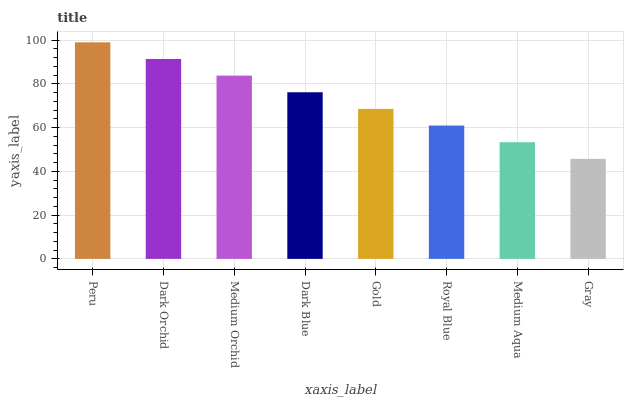Is Gray the minimum?
Answer yes or no. Yes. Is Peru the maximum?
Answer yes or no. Yes. Is Dark Orchid the minimum?
Answer yes or no. No. Is Dark Orchid the maximum?
Answer yes or no. No. Is Peru greater than Dark Orchid?
Answer yes or no. Yes. Is Dark Orchid less than Peru?
Answer yes or no. Yes. Is Dark Orchid greater than Peru?
Answer yes or no. No. Is Peru less than Dark Orchid?
Answer yes or no. No. Is Dark Blue the high median?
Answer yes or no. Yes. Is Gold the low median?
Answer yes or no. Yes. Is Medium Orchid the high median?
Answer yes or no. No. Is Gray the low median?
Answer yes or no. No. 